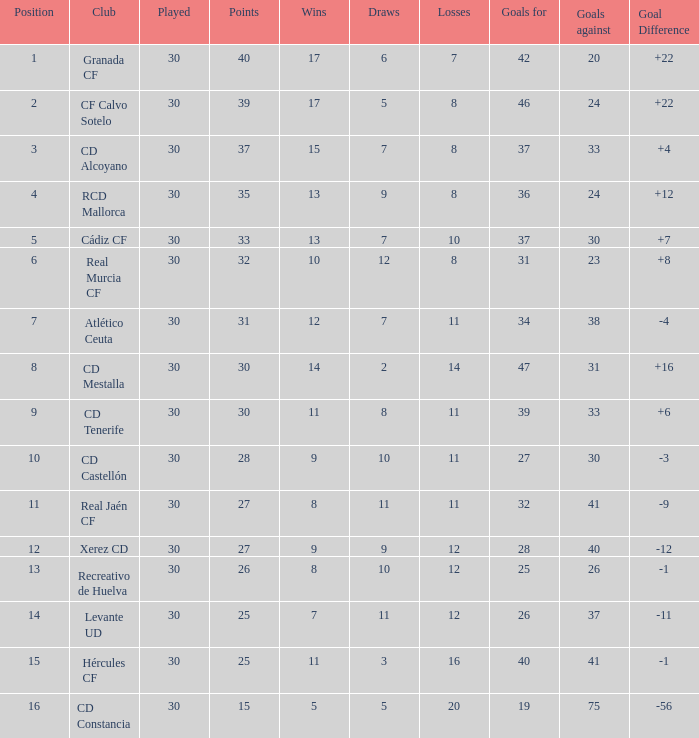How many Draws have 30 Points, and less than 33 Goals against? 1.0. 